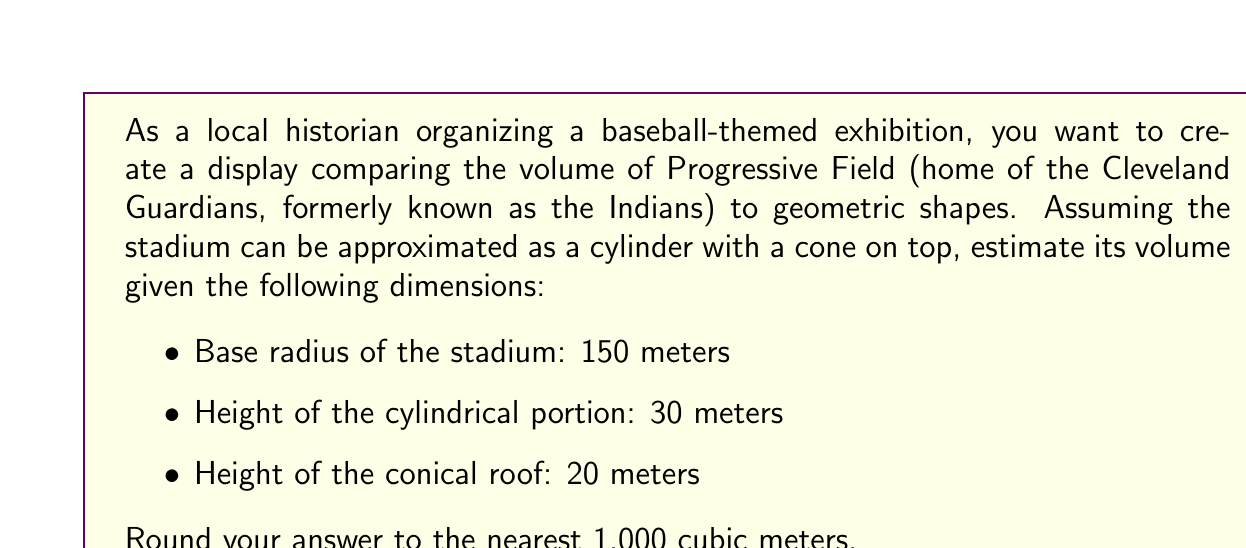Teach me how to tackle this problem. To solve this problem, we need to calculate the volume of the cylinder and the cone separately, then add them together.

1. Volume of the cylinder:
   The formula for the volume of a cylinder is $V_c = \pi r^2 h$
   where $r$ is the radius and $h$ is the height.

   $$V_c = \pi \cdot 150^2 \cdot 30 = 2,120,575.5 \text{ m}^3$$

2. Volume of the cone:
   The formula for the volume of a cone is $V_n = \frac{1}{3} \pi r^2 h$
   where $r$ is the radius and $h$ is the height.

   $$V_n = \frac{1}{3} \pi \cdot 150^2 \cdot 20 = 471,238.9 \text{ m}^3$$

3. Total volume:
   $$V_{\text{total}} = V_c + V_n = 2,120,575.5 + 471,238.9 = 2,591,814.4 \text{ m}^3$$

4. Rounding to the nearest 1,000 cubic meters:
   $$2,591,814.4 \text{ m}^3 \approx 2,592,000 \text{ m}^3$$

[asy]
import three;

size(200);
currentprojection=perspective(6,3,2);

real r = 2;
real h1 = 0.4;
real h2 = 0.3;

draw(cylinder((0,0,0),r,h1));
draw(cone((0,0,h1),r,h2));

label("Cylinder", (r+0.5,0,h1/2));
label("Cone", (r+0.5,0,h1+h2/2));
[/asy]
Answer: The estimated volume of Progressive Field is approximately 2,592,000 cubic meters. 